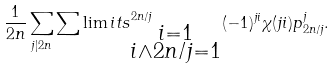<formula> <loc_0><loc_0><loc_500><loc_500>\frac { 1 } { 2 n } \sum _ { j | 2 n } \sum \lim i t s _ { \substack { i = 1 \\ i \wedge 2 n / j = 1 } } ^ { 2 n / j } ( - 1 ) ^ { j i } \chi ( j i ) p _ { 2 n / j } ^ { j } .</formula> 